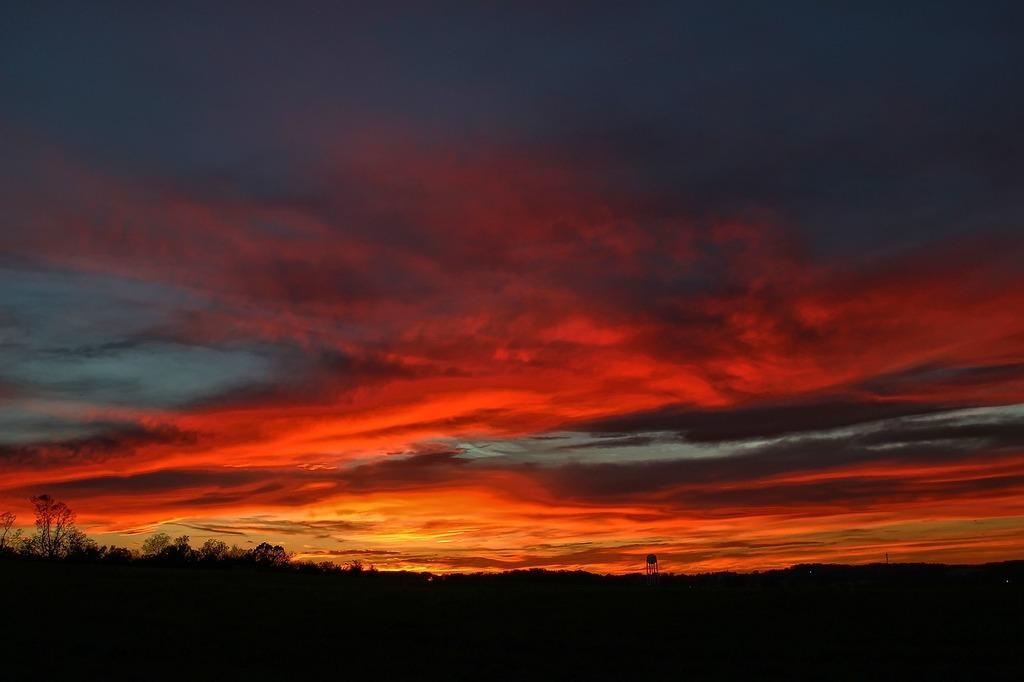Describe this image in one or two sentences. In this picture we can see trees and in the background we can see the sky with clouds. 